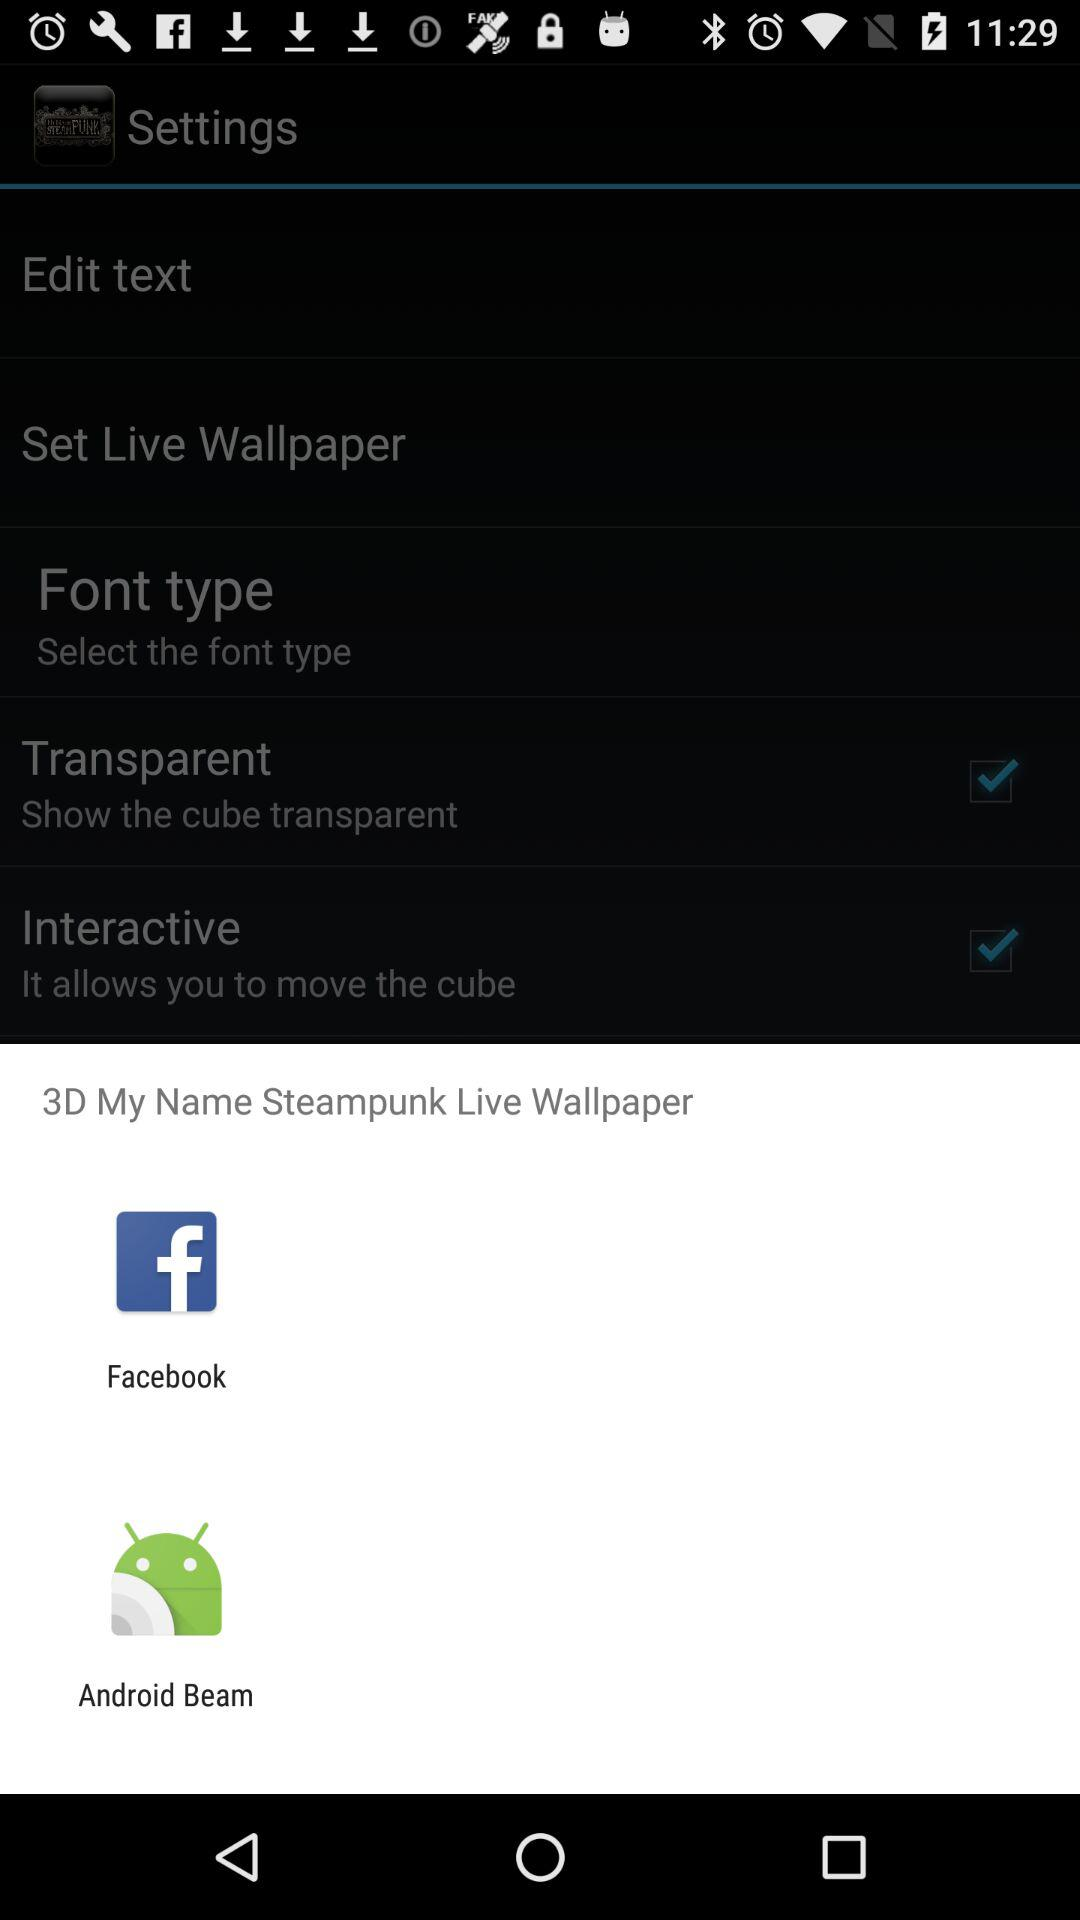What is the selected font type?
When the provided information is insufficient, respond with <no answer>. <no answer> 